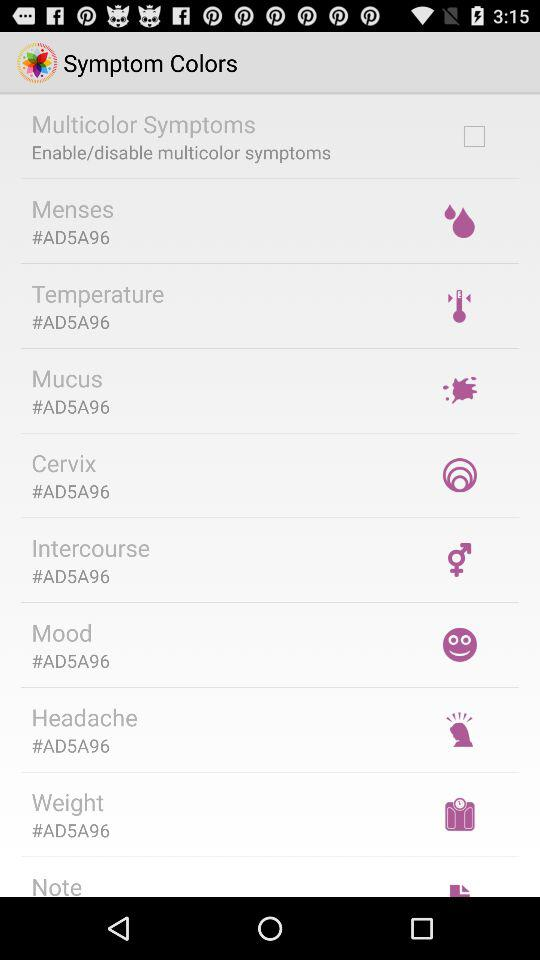What is the code of the cervix? The code of the cervix is #AD5A96. 